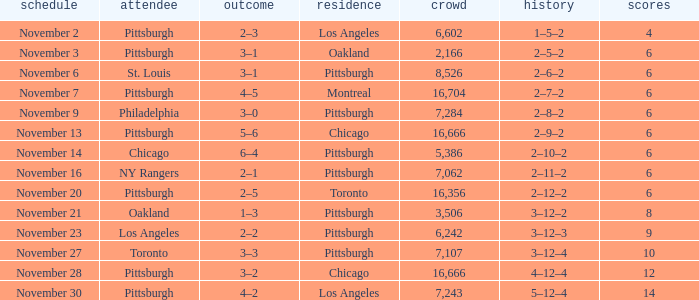What is the lowest amount of points of the game with toronto as the home team? 6.0. 